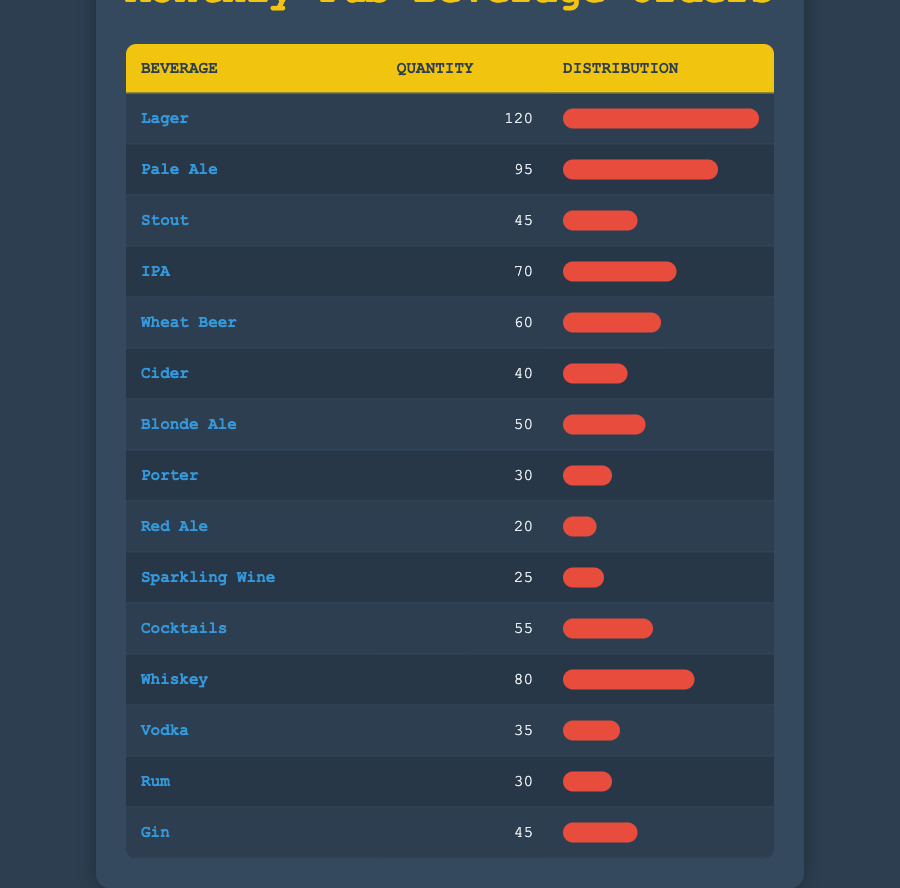What was the highest quantity of beverages ordered? The table shows that Lager has the highest quantity ordered with 120.
Answer: 120 Which beverage was ordered more, Whiskey or IPA? Whiskey has 80 orders while IPA has 70 orders, so Whiskey was ordered more.
Answer: Whiskey What is the total quantity of Cider and Blonde Ale combined? Cider has 40 and Blonde Ale has 50. Adding them gives 40 + 50 = 90.
Answer: 90 Did more than 100 beverages of Lager was ordered? The quantity for Lager is 120, which is more than 100.
Answer: Yes Which beverage has a quantity closest to 50? Wheat Beer has 60, Blonde Ale has 50, and Cocktails have 55, so Blonde Ale is exactly 50.
Answer: Blonde Ale What is the average quantity of all beverages listed in the table? To compute the average, we first sum the quantities: 120 + 95 + 45 + 70 + 60 + 40 + 50 + 30 + 20 + 25 + 55 + 80 + 35 + 30 + 45 =  715. There are 15 beverages, so the average is 715 / 15 = 47.67.
Answer: 47.67 Which two beverages have the least quantity ordered? The two beverages with the least quantities are Red Ale with 20 and Porter with 30.
Answer: Red Ale and Porter Are there more types of beer or spirits ordered in the pub? There are 9 types of beer (Lager, Pale Ale, Stout, IPA, Wheat Beer, Blonde Ale, Cider, Porter, Red Ale) and 6 types of spirits (Whiskey, Vodka, Rum, Gin, Cocktails, Sparkling Wine). Thus, there are more types of beer.
Answer: Beer What percentage of the total quantity does the Pale Ale represent? First, sum all the beverages for the total quantity: 715. Pale Ale is 95, so (95 / 715) * 100 = 13.28%.
Answer: 13.28% 